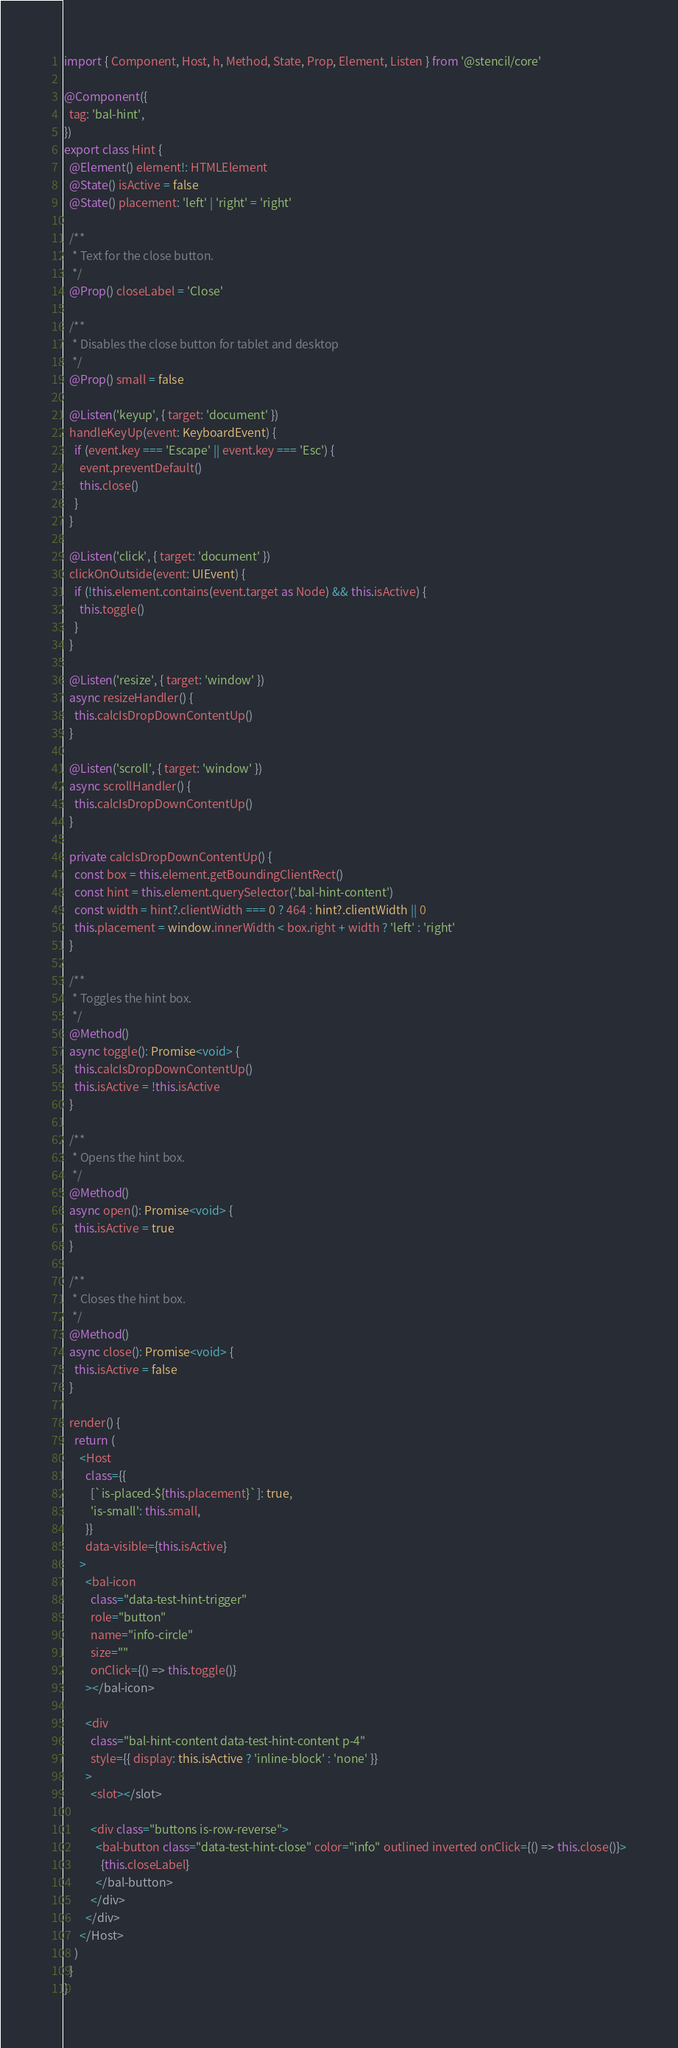<code> <loc_0><loc_0><loc_500><loc_500><_TypeScript_>import { Component, Host, h, Method, State, Prop, Element, Listen } from '@stencil/core'

@Component({
  tag: 'bal-hint',
})
export class Hint {
  @Element() element!: HTMLElement
  @State() isActive = false
  @State() placement: 'left' | 'right' = 'right'

  /**
   * Text for the close button.
   */
  @Prop() closeLabel = 'Close'

  /**
   * Disables the close button for tablet and desktop
   */
  @Prop() small = false

  @Listen('keyup', { target: 'document' })
  handleKeyUp(event: KeyboardEvent) {
    if (event.key === 'Escape' || event.key === 'Esc') {
      event.preventDefault()
      this.close()
    }
  }

  @Listen('click', { target: 'document' })
  clickOnOutside(event: UIEvent) {
    if (!this.element.contains(event.target as Node) && this.isActive) {
      this.toggle()
    }
  }

  @Listen('resize', { target: 'window' })
  async resizeHandler() {
    this.calcIsDropDownContentUp()
  }

  @Listen('scroll', { target: 'window' })
  async scrollHandler() {
    this.calcIsDropDownContentUp()
  }

  private calcIsDropDownContentUp() {
    const box = this.element.getBoundingClientRect()
    const hint = this.element.querySelector('.bal-hint-content')
    const width = hint?.clientWidth === 0 ? 464 : hint?.clientWidth || 0
    this.placement = window.innerWidth < box.right + width ? 'left' : 'right'
  }

  /**
   * Toggles the hint box.
   */
  @Method()
  async toggle(): Promise<void> {
    this.calcIsDropDownContentUp()
    this.isActive = !this.isActive
  }

  /**
   * Opens the hint box.
   */
  @Method()
  async open(): Promise<void> {
    this.isActive = true
  }

  /**
   * Closes the hint box.
   */
  @Method()
  async close(): Promise<void> {
    this.isActive = false
  }

  render() {
    return (
      <Host
        class={{
          [`is-placed-${this.placement}`]: true,
          'is-small': this.small,
        }}
        data-visible={this.isActive}
      >
        <bal-icon
          class="data-test-hint-trigger"
          role="button"
          name="info-circle"
          size=""
          onClick={() => this.toggle()}
        ></bal-icon>

        <div
          class="bal-hint-content data-test-hint-content p-4"
          style={{ display: this.isActive ? 'inline-block' : 'none' }}
        >
          <slot></slot>

          <div class="buttons is-row-reverse">
            <bal-button class="data-test-hint-close" color="info" outlined inverted onClick={() => this.close()}>
              {this.closeLabel}
            </bal-button>
          </div>
        </div>
      </Host>
    )
  }
}
</code> 